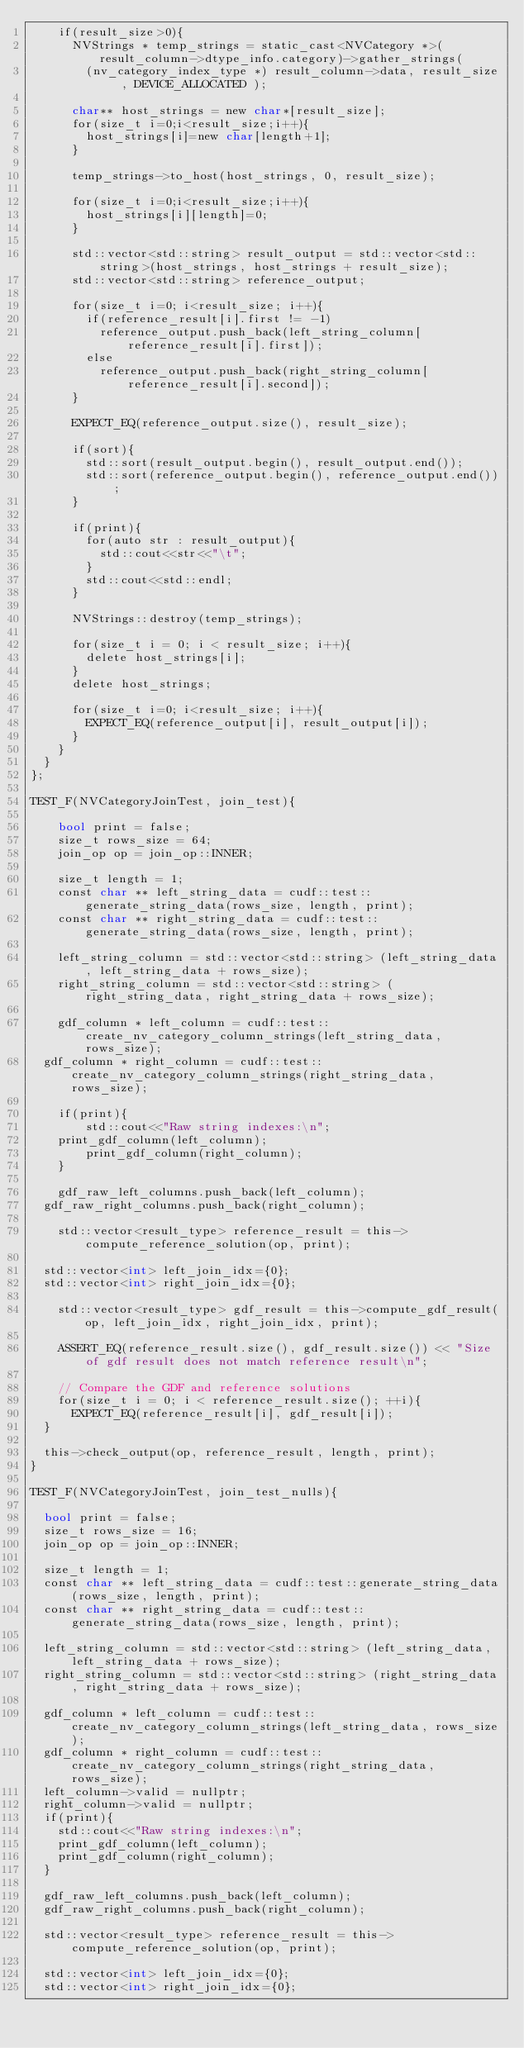Convert code to text. <code><loc_0><loc_0><loc_500><loc_500><_Cuda_>    if(result_size>0){
      NVStrings * temp_strings = static_cast<NVCategory *>(result_column->dtype_info.category)->gather_strings( 
        (nv_category_index_type *) result_column->data, result_size , DEVICE_ALLOCATED );

      char** host_strings = new char*[result_size];
      for(size_t i=0;i<result_size;i++){
        host_strings[i]=new char[length+1];
      }

      temp_strings->to_host(host_strings, 0, result_size);

      for(size_t i=0;i<result_size;i++){
        host_strings[i][length]=0;
      }

      std::vector<std::string> result_output = std::vector<std::string>(host_strings, host_strings + result_size);
      std::vector<std::string> reference_output;

      for(size_t i=0; i<result_size; i++){
        if(reference_result[i].first != -1)
          reference_output.push_back(left_string_column[reference_result[i].first]);
        else
          reference_output.push_back(right_string_column[reference_result[i].second]);
      }

      EXPECT_EQ(reference_output.size(), result_size);

      if(sort){
        std::sort(result_output.begin(), result_output.end());
        std::sort(reference_output.begin(), reference_output.end());
      }

      if(print){
        for(auto str : result_output){
          std::cout<<str<<"\t";
        }
        std::cout<<std::endl;
      }

      NVStrings::destroy(temp_strings);

      for(size_t i = 0; i < result_size; i++){
        delete host_strings[i];
      }
      delete host_strings;

      for(size_t i=0; i<result_size; i++){
        EXPECT_EQ(reference_output[i], result_output[i]);
      }
    }
  }
};

TEST_F(NVCategoryJoinTest, join_test){

	bool print = false;
	size_t rows_size = 64;
	join_op op = join_op::INNER;

	size_t length = 1;
	const char ** left_string_data = cudf::test::generate_string_data(rows_size, length, print);
	const char ** right_string_data = cudf::test::generate_string_data(rows_size, length, print);

	left_string_column = std::vector<std::string> (left_string_data, left_string_data + rows_size);
	right_string_column = std::vector<std::string> (right_string_data, right_string_data + rows_size);

	gdf_column * left_column = cudf::test::create_nv_category_column_strings(left_string_data, rows_size);
  gdf_column * right_column = cudf::test::create_nv_category_column_strings(right_string_data, rows_size);
	
	if(print){
		std::cout<<"Raw string indexes:\n";
    print_gdf_column(left_column);
		print_gdf_column(right_column);
	}

	gdf_raw_left_columns.push_back(left_column);
  gdf_raw_right_columns.push_back(right_column);

	std::vector<result_type> reference_result = this->compute_reference_solution(op, print);

  std::vector<int> left_join_idx={0};
  std::vector<int> right_join_idx={0};

	std::vector<result_type> gdf_result = this->compute_gdf_result(op, left_join_idx, right_join_idx, print);

	ASSERT_EQ(reference_result.size(), gdf_result.size()) << "Size of gdf result does not match reference result\n";

	// Compare the GDF and reference solutions
	for(size_t i = 0; i < reference_result.size(); ++i){
	  EXPECT_EQ(reference_result[i], gdf_result[i]);
  }

  this->check_output(op, reference_result, length, print);
}

TEST_F(NVCategoryJoinTest, join_test_nulls){

  bool print = false;
  size_t rows_size = 16;
  join_op op = join_op::INNER;

  size_t length = 1;
  const char ** left_string_data = cudf::test::generate_string_data(rows_size, length, print);
  const char ** right_string_data = cudf::test::generate_string_data(rows_size, length, print);

  left_string_column = std::vector<std::string> (left_string_data, left_string_data + rows_size);
  right_string_column = std::vector<std::string> (right_string_data, right_string_data + rows_size);

  gdf_column * left_column = cudf::test::create_nv_category_column_strings(left_string_data, rows_size);
  gdf_column * right_column = cudf::test::create_nv_category_column_strings(right_string_data, rows_size);
  left_column->valid = nullptr;
  right_column->valid = nullptr;
  if(print){
    std::cout<<"Raw string indexes:\n";
    print_gdf_column(left_column);
    print_gdf_column(right_column);
  }

  gdf_raw_left_columns.push_back(left_column);
  gdf_raw_right_columns.push_back(right_column);

  std::vector<result_type> reference_result = this->compute_reference_solution(op, print);

  std::vector<int> left_join_idx={0};
  std::vector<int> right_join_idx={0};
</code> 